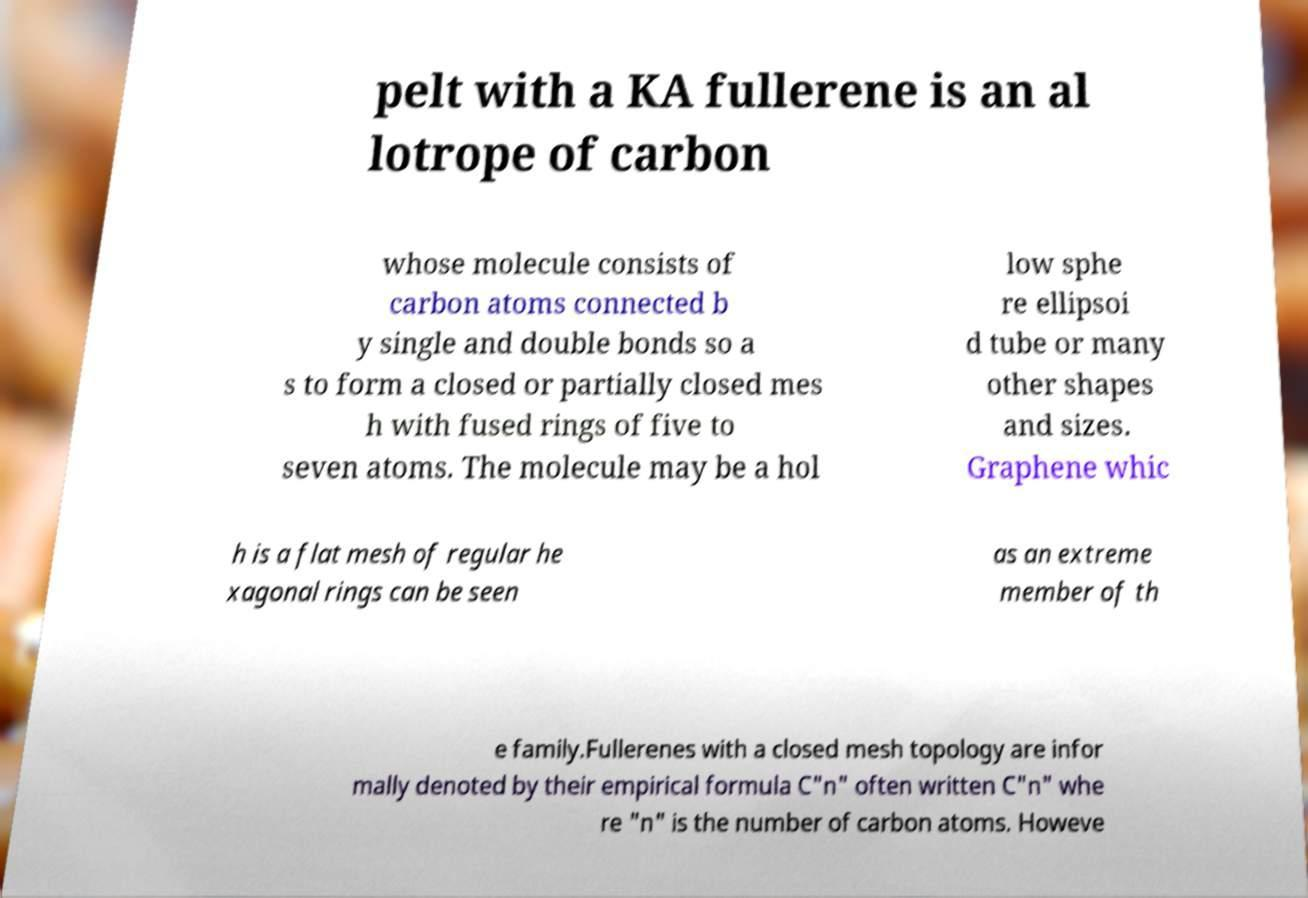What messages or text are displayed in this image? I need them in a readable, typed format. pelt with a KA fullerene is an al lotrope of carbon whose molecule consists of carbon atoms connected b y single and double bonds so a s to form a closed or partially closed mes h with fused rings of five to seven atoms. The molecule may be a hol low sphe re ellipsoi d tube or many other shapes and sizes. Graphene whic h is a flat mesh of regular he xagonal rings can be seen as an extreme member of th e family.Fullerenes with a closed mesh topology are infor mally denoted by their empirical formula C"n" often written C"n" whe re "n" is the number of carbon atoms. Howeve 